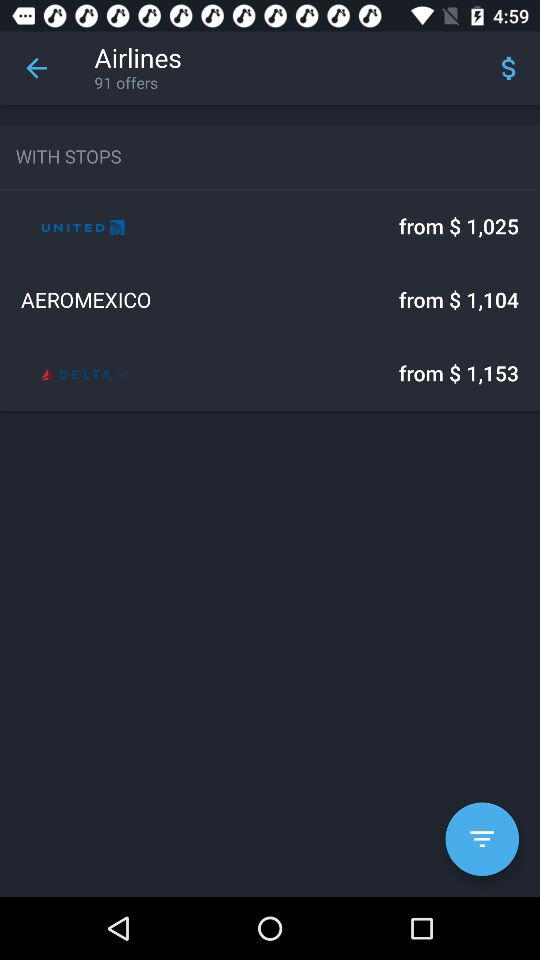What is the starting price of Delta Airlines? The starting price is $ 1,153. 